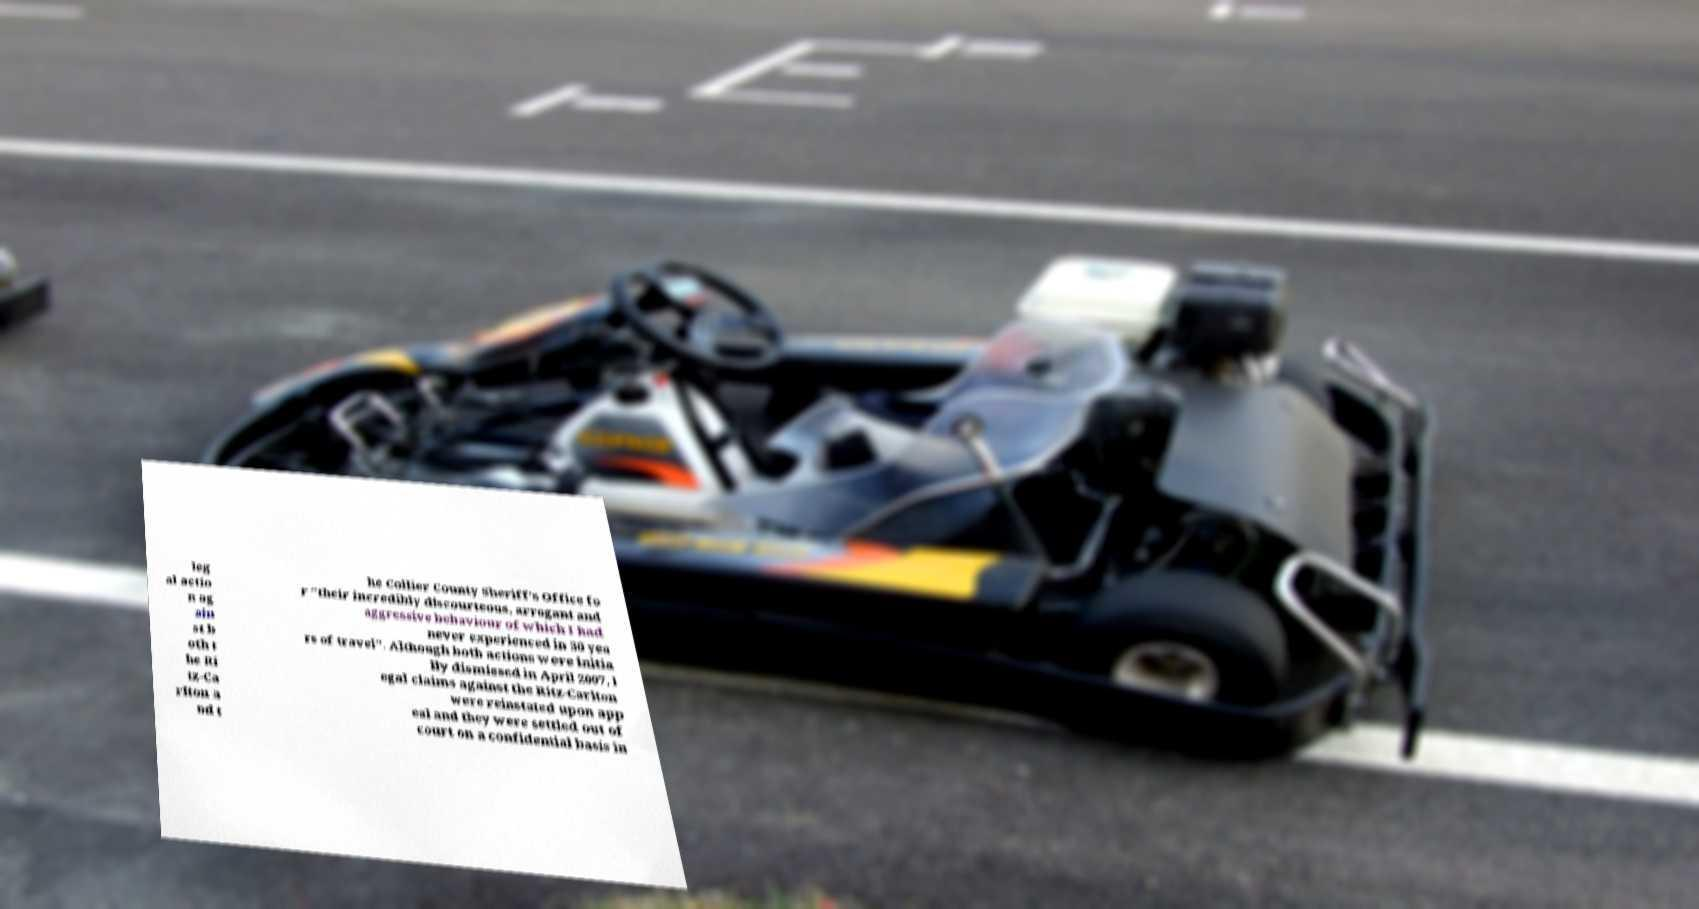Please identify and transcribe the text found in this image. leg al actio n ag ain st b oth t he Ri tz-Ca rlton a nd t he Collier County Sheriff's Office fo r "their incredibly discourteous, arrogant and aggressive behaviour of which I had never experienced in 30 yea rs of travel". Although both actions were initia lly dismissed in April 2007, l egal claims against the Ritz-Carlton were reinstated upon app eal and they were settled out of court on a confidential basis in 